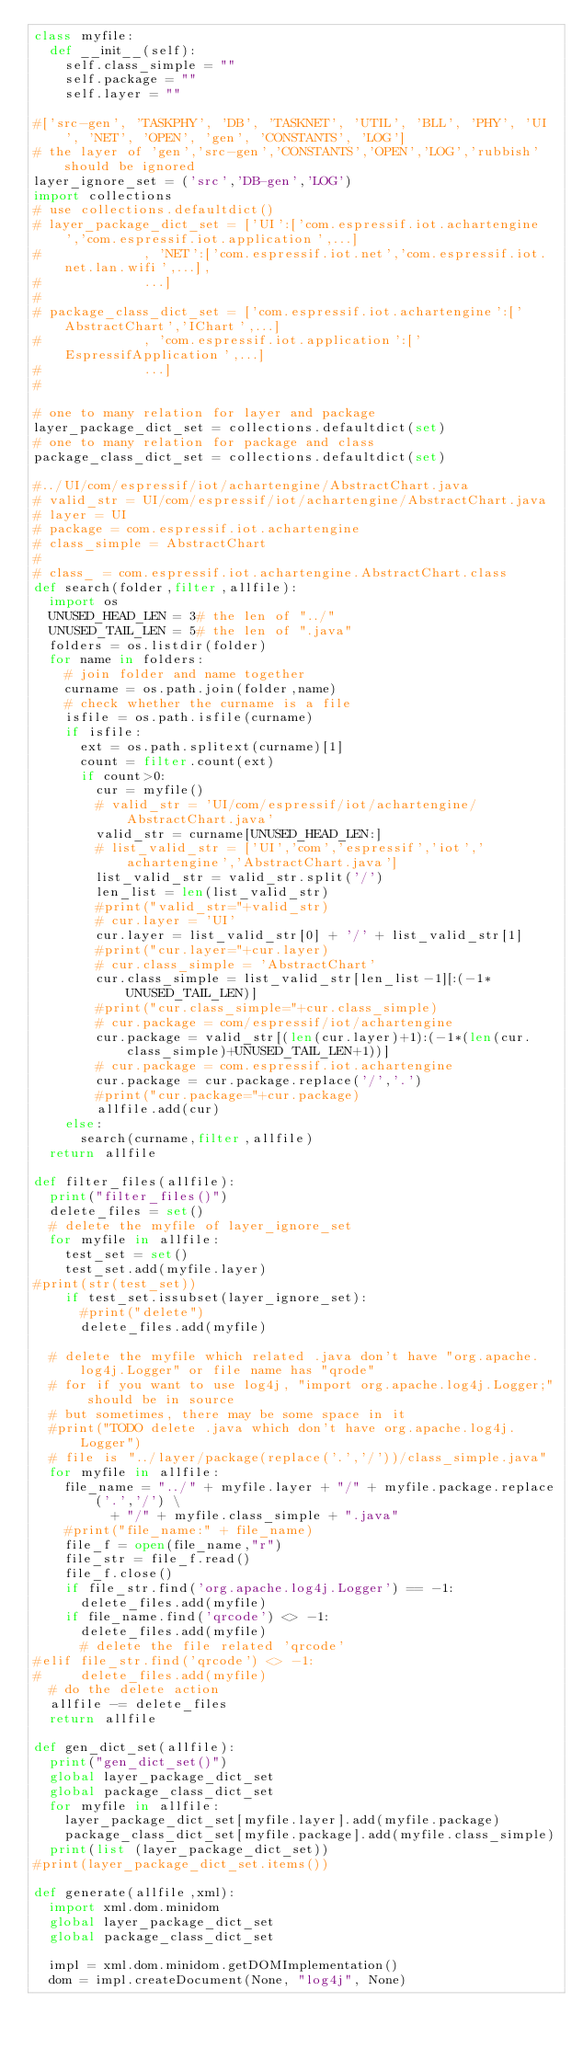Convert code to text. <code><loc_0><loc_0><loc_500><loc_500><_Python_>class myfile:
	def __init__(self):
		self.class_simple = ""
		self.package = ""
		self.layer = ""

#['src-gen', 'TASKPHY', 'DB', 'TASKNET', 'UTIL', 'BLL', 'PHY', 'UI', 'NET', 'OPEN', 'gen', 'CONSTANTS', 'LOG']
# the layer of 'gen','src-gen','CONSTANTS','OPEN','LOG','rubbish' should be ignored
layer_ignore_set = ('src','DB-gen','LOG')
import collections
# use collections.defaultdict()
# layer_package_dict_set = ['UI':['com.espressif.iot.achartengine','com.espressif.iot.application',...]
#							, 'NET':['com.espressif.iot.net','com.espressif.iot.net.lan.wifi',...], 
#							...]
#
# package_class_dict_set = ['com.espressif.iot.achartengine':['AbstractChart','IChart',...]
#							, 'com.espressif.iot.application':['EspressifApplication',...]
#							...]
#

# one to many relation for layer and package
layer_package_dict_set = collections.defaultdict(set)
# one to many relation for package and class
package_class_dict_set = collections.defaultdict(set)

#../UI/com/espressif/iot/achartengine/AbstractChart.java
# valid_str = UI/com/espressif/iot/achartengine/AbstractChart.java
# layer = UI
# package = com.espressif.iot.achartengine
# class_simple = AbstractChart
#
# class_ = com.espressif.iot.achartengine.AbstractChart.class
def search(folder,filter,allfile):
	import os
	UNUSED_HEAD_LEN = 3# the len of "../"
	UNUSED_TAIL_LEN = 5# the len of ".java"
	folders = os.listdir(folder)
	for name in folders:
		# join folder and name together
		curname = os.path.join(folder,name)
		# check whether the curname is a file
		isfile = os.path.isfile(curname)
		if isfile:
			ext = os.path.splitext(curname)[1]
			count = filter.count(ext)
			if count>0:
				cur = myfile()
				# valid_str = 'UI/com/espressif/iot/achartengine/AbstractChart.java'
				valid_str = curname[UNUSED_HEAD_LEN:]
				# list_valid_str = ['UI','com','espressif','iot','achartengine','AbstractChart.java']
				list_valid_str = valid_str.split('/')
				len_list = len(list_valid_str)
				#print("valid_str="+valid_str)
				# cur.layer = 'UI'
				cur.layer = list_valid_str[0] + '/' + list_valid_str[1]
				#print("cur.layer="+cur.layer)
				# cur.class_simple = 'AbstractChart'
				cur.class_simple = list_valid_str[len_list-1][:(-1*UNUSED_TAIL_LEN)]
				#print("cur.class_simple="+cur.class_simple)
				# cur.package = com/espressif/iot/achartengine
				cur.package = valid_str[(len(cur.layer)+1):(-1*(len(cur.class_simple)+UNUSED_TAIL_LEN+1))]
				# cur.package = com.espressif.iot.achartengine
				cur.package = cur.package.replace('/','.')
				#print("cur.package="+cur.package)
				allfile.add(cur)
		else:
			search(curname,filter,allfile)
	return allfile

def filter_files(allfile):
	print("filter_files()")
	delete_files = set()
	# delete the myfile of layer_ignore_set
	for myfile in allfile:
		test_set = set()
		test_set.add(myfile.layer)
#print(str(test_set))
		if test_set.issubset(layer_ignore_set):
			#print("delete")
			delete_files.add(myfile)

	# delete the myfile which related .java don't have "org.apache.log4j.Logger" or file name has "qrode"
	# for if you want to use log4j, "import org.apache.log4j.Logger;" should be in source
	# but sometimes, there may be some space in it 
	#print("TODO delete .java which don't have org.apache.log4j.Logger")
	# file is "../layer/package(replace('.','/'))/class_simple.java"
	for myfile in allfile:
		file_name = "../" + myfile.layer + "/" + myfile.package.replace('.','/') \
					+ "/" + myfile.class_simple + ".java"
		#print("file_name:" + file_name)
		file_f = open(file_name,"r")
		file_str = file_f.read()
		file_f.close()
		if file_str.find('org.apache.log4j.Logger') == -1:
			delete_files.add(myfile)
		if file_name.find('qrcode') <> -1:
			delete_files.add(myfile)
	    # delete the file related 'qrcode'
#elif file_str.find('qrcode') <> -1:
#			delete_files.add(myfile)
	# do the delete action
	allfile -= delete_files
	return allfile

def gen_dict_set(allfile):
	print("gen_dict_set()")
	global layer_package_dict_set
	global package_class_dict_set
	for myfile in allfile:
		layer_package_dict_set[myfile.layer].add(myfile.package)
		package_class_dict_set[myfile.package].add(myfile.class_simple)
	print(list (layer_package_dict_set))
#print(layer_package_dict_set.items())

def generate(allfile,xml):
	import xml.dom.minidom
	global layer_package_dict_set
	global package_class_dict_set

	impl = xml.dom.minidom.getDOMImplementation()
	dom = impl.createDocument(None, "log4j", None)</code> 